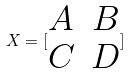Convert formula to latex. <formula><loc_0><loc_0><loc_500><loc_500>X = [ \begin{matrix} A & B \\ C & D \end{matrix} ]</formula> 